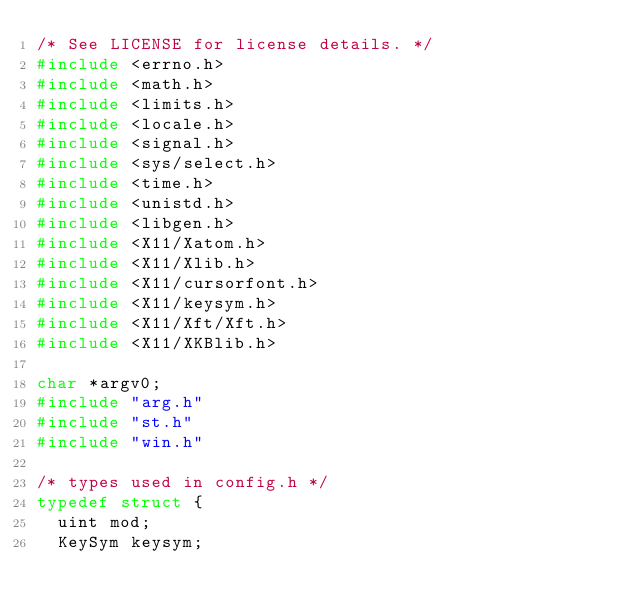<code> <loc_0><loc_0><loc_500><loc_500><_C_>/* See LICENSE for license details. */
#include <errno.h>
#include <math.h>
#include <limits.h>
#include <locale.h>
#include <signal.h>
#include <sys/select.h>
#include <time.h>
#include <unistd.h>
#include <libgen.h>
#include <X11/Xatom.h>
#include <X11/Xlib.h>
#include <X11/cursorfont.h>
#include <X11/keysym.h>
#include <X11/Xft/Xft.h>
#include <X11/XKBlib.h>

char *argv0;
#include "arg.h"
#include "st.h"
#include "win.h"

/* types used in config.h */
typedef struct {
	uint mod;
	KeySym keysym;</code> 